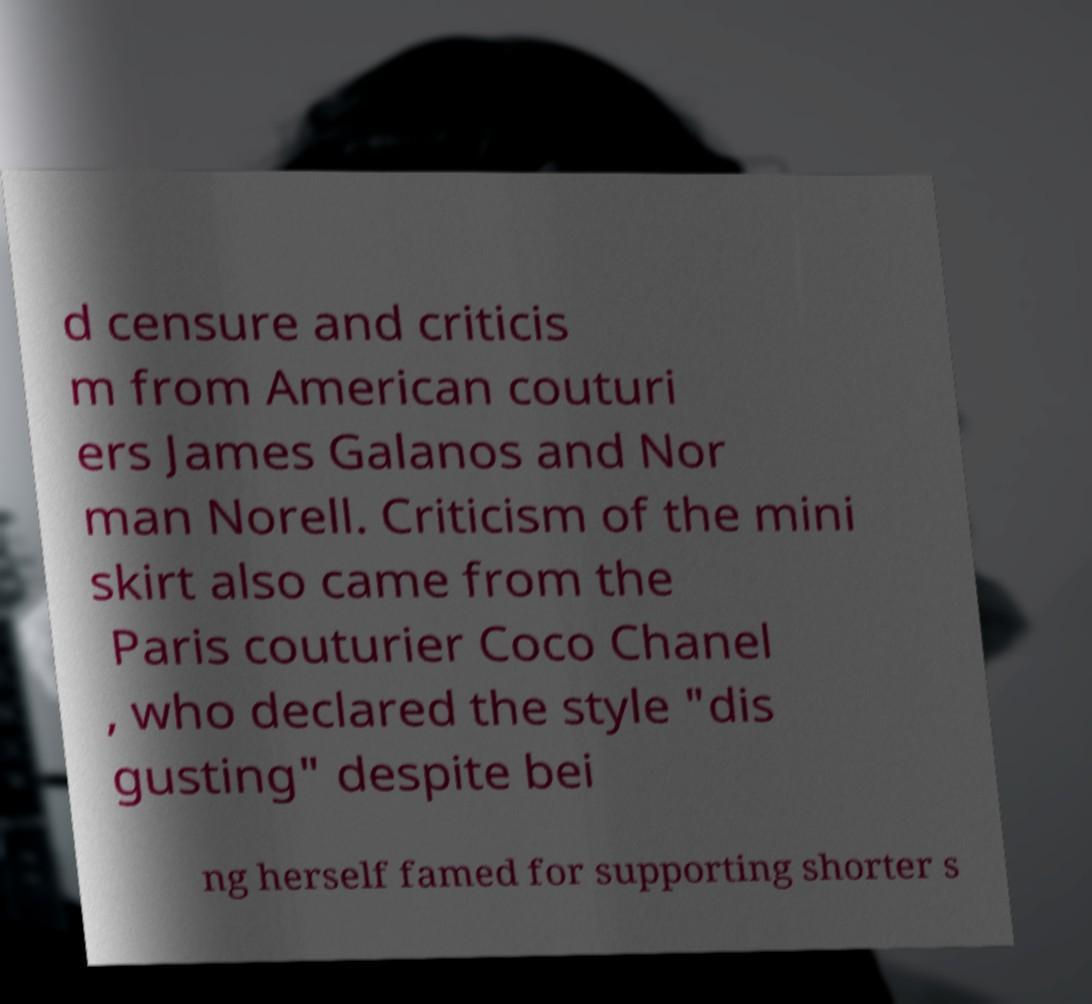Could you assist in decoding the text presented in this image and type it out clearly? d censure and criticis m from American couturi ers James Galanos and Nor man Norell. Criticism of the mini skirt also came from the Paris couturier Coco Chanel , who declared the style "dis gusting" despite bei ng herself famed for supporting shorter s 